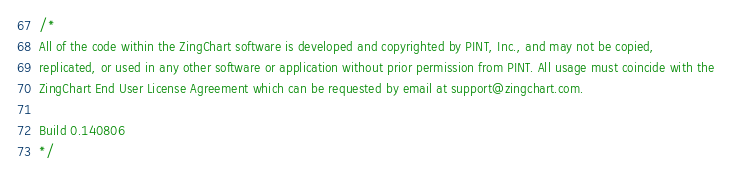Convert code to text. <code><loc_0><loc_0><loc_500><loc_500><_JavaScript_>/*
All of the code within the ZingChart software is developed and copyrighted by PINT, Inc., and may not be copied,
replicated, or used in any other software or application without prior permission from PINT. All usage must coincide with the
ZingChart End User License Agreement which can be requested by email at support@zingchart.com.

Build 0.140806
*/</code> 